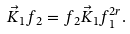<formula> <loc_0><loc_0><loc_500><loc_500>\vec { K } _ { 1 } f _ { 2 } = f _ { 2 } \vec { K } _ { 1 } f _ { 1 } ^ { 2 r } .</formula> 